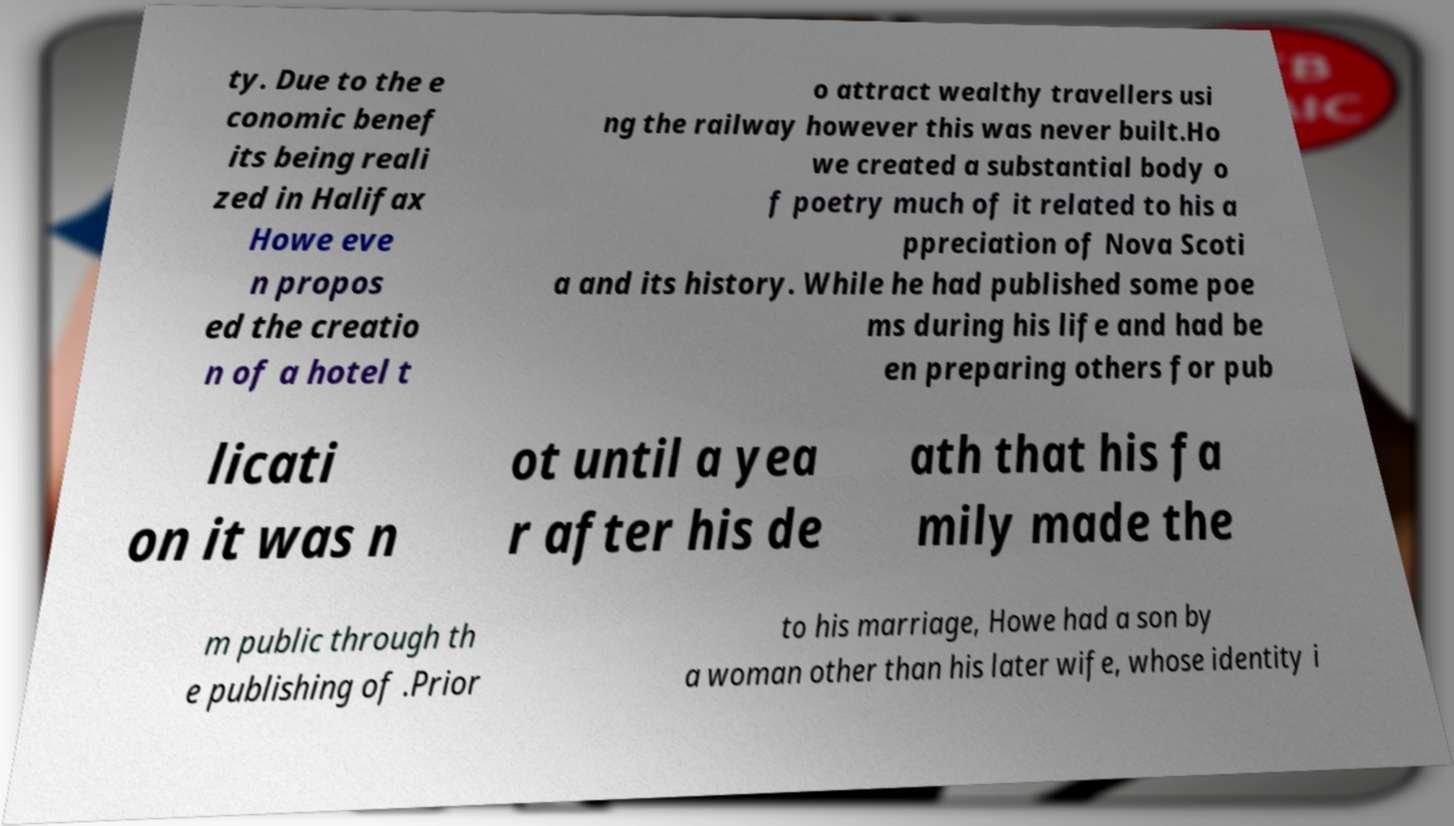Please identify and transcribe the text found in this image. ty. Due to the e conomic benef its being reali zed in Halifax Howe eve n propos ed the creatio n of a hotel t o attract wealthy travellers usi ng the railway however this was never built.Ho we created a substantial body o f poetry much of it related to his a ppreciation of Nova Scoti a and its history. While he had published some poe ms during his life and had be en preparing others for pub licati on it was n ot until a yea r after his de ath that his fa mily made the m public through th e publishing of .Prior to his marriage, Howe had a son by a woman other than his later wife, whose identity i 